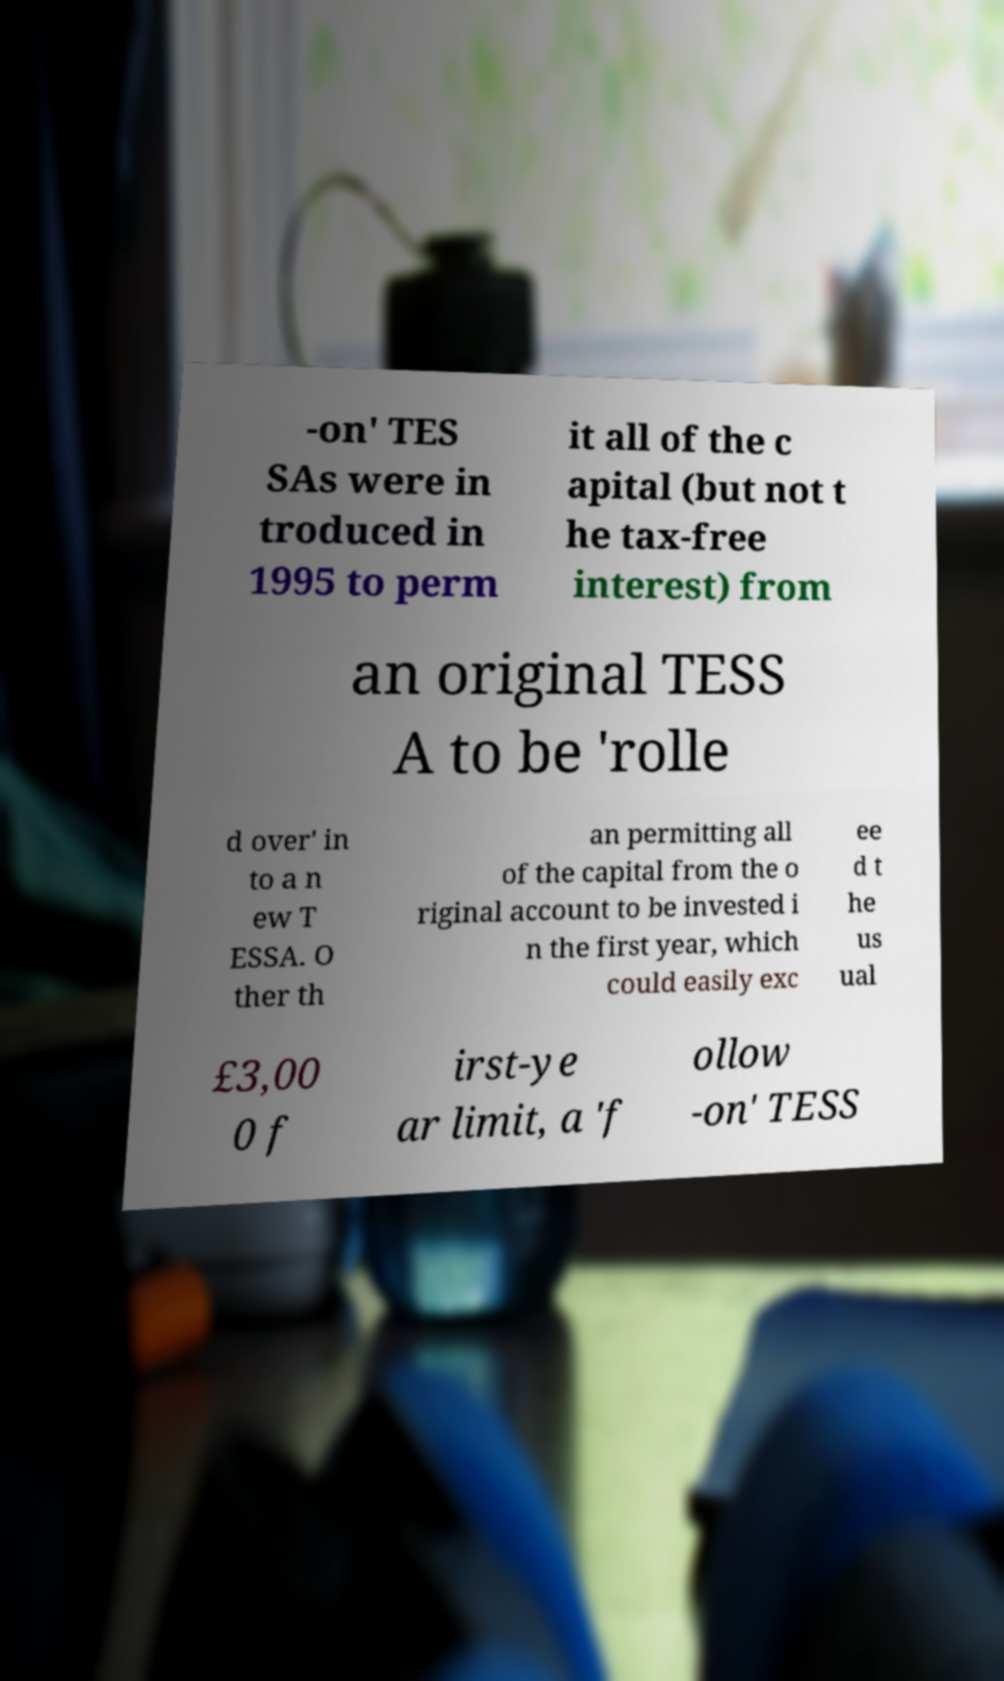Can you accurately transcribe the text from the provided image for me? -on' TES SAs were in troduced in 1995 to perm it all of the c apital (but not t he tax-free interest) from an original TESS A to be 'rolle d over' in to a n ew T ESSA. O ther th an permitting all of the capital from the o riginal account to be invested i n the first year, which could easily exc ee d t he us ual £3,00 0 f irst-ye ar limit, a 'f ollow -on' TESS 